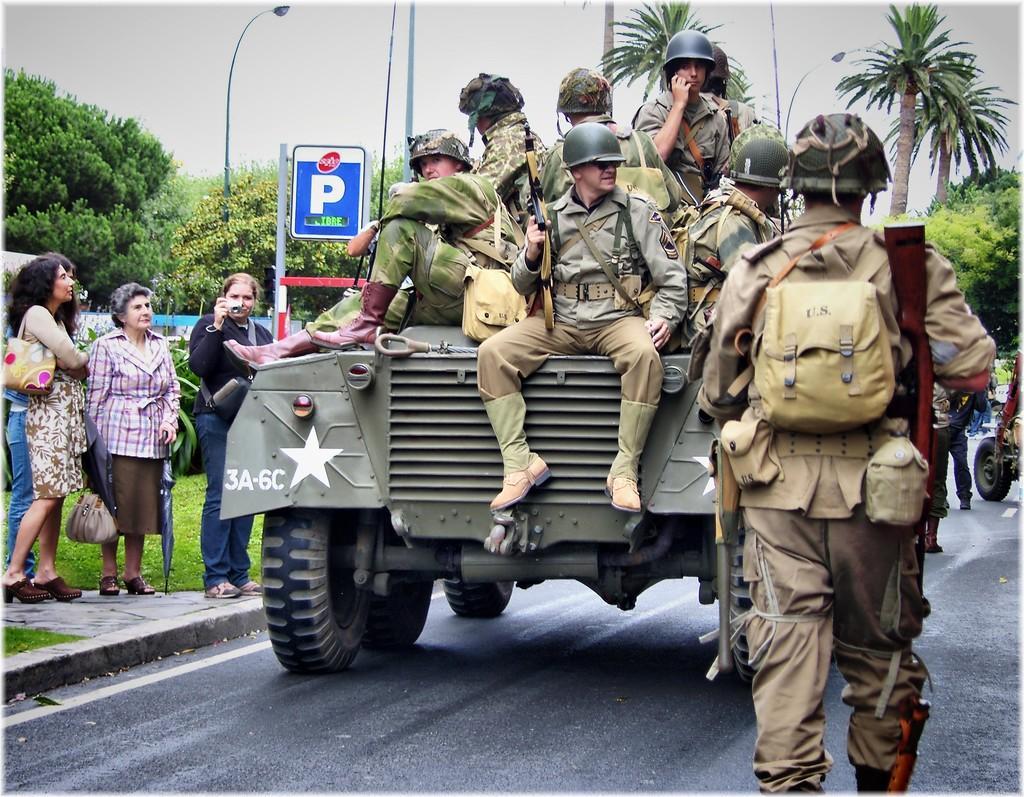Could you give a brief overview of what you see in this image? In this image I can see few people sitting on the military tanker wearing military uniforms and holding guns and wearing helmets. I can see a person wearing military uniform, a bag and helmet is walking and holding a gun. In the background I can see few people standing on the sidewalk ,a sign board ,few trees,a light pole and the sky. 